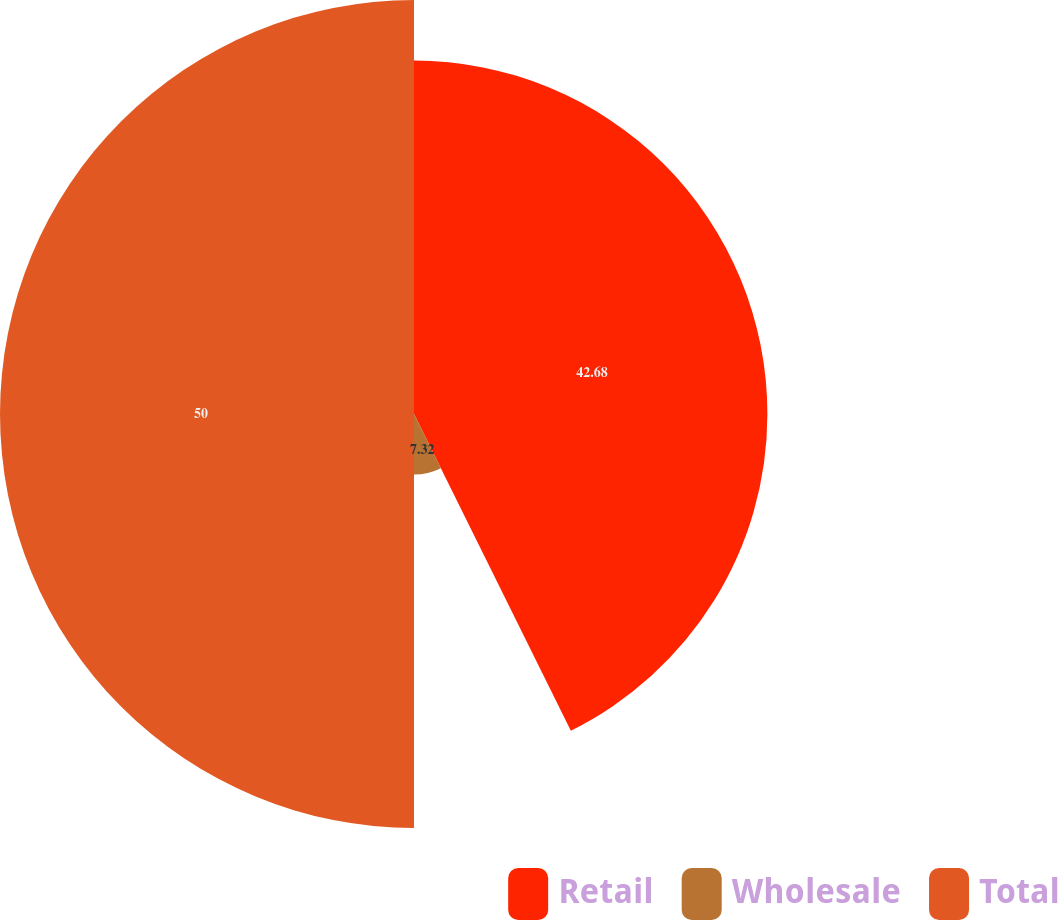Convert chart. <chart><loc_0><loc_0><loc_500><loc_500><pie_chart><fcel>Retail<fcel>Wholesale<fcel>Total<nl><fcel>42.68%<fcel>7.32%<fcel>50.0%<nl></chart> 